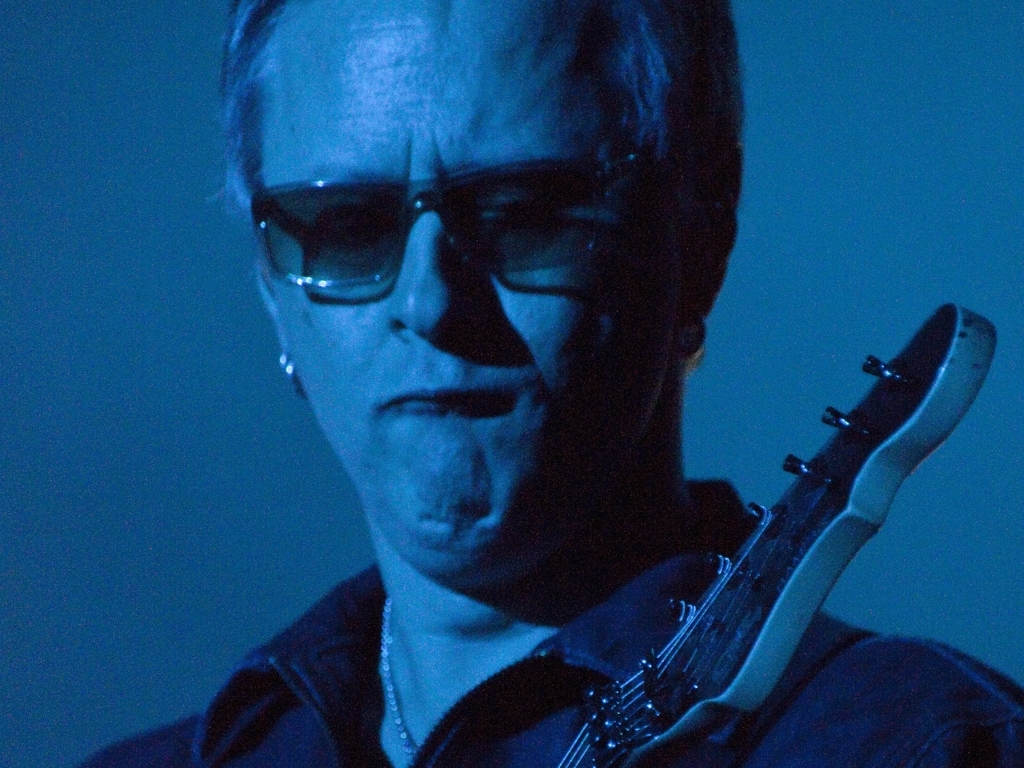Is the image quality poor? Yes, the image quality is poor, primarily due to low lighting and noticeable graininess across the photo. This might affect the visibility of finer details and textures in the image. 